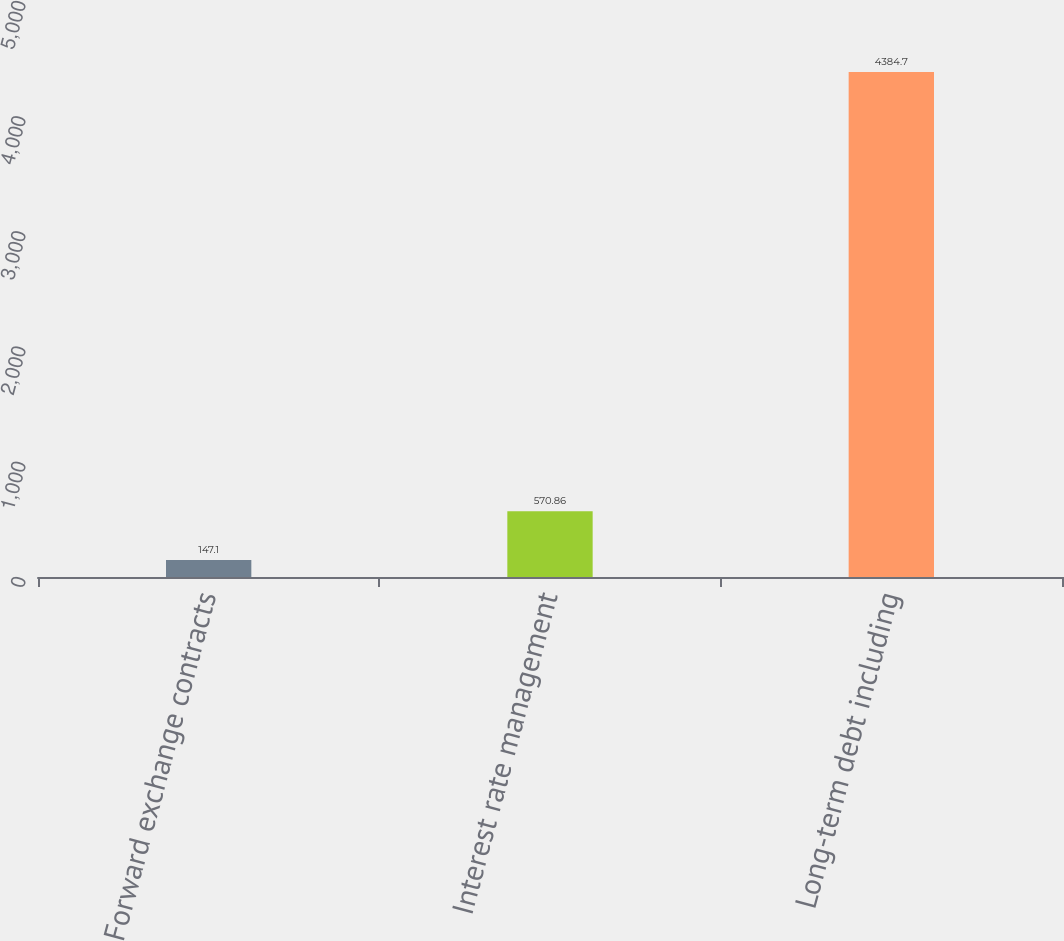Convert chart to OTSL. <chart><loc_0><loc_0><loc_500><loc_500><bar_chart><fcel>Forward exchange contracts<fcel>Interest rate management<fcel>Long-term debt including<nl><fcel>147.1<fcel>570.86<fcel>4384.7<nl></chart> 